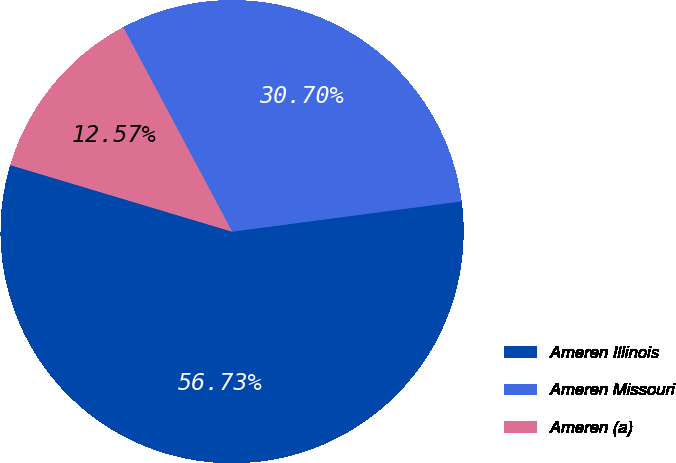<chart> <loc_0><loc_0><loc_500><loc_500><pie_chart><fcel>Ameren Illinois<fcel>Ameren Missouri<fcel>Ameren (a)<nl><fcel>56.73%<fcel>30.7%<fcel>12.57%<nl></chart> 